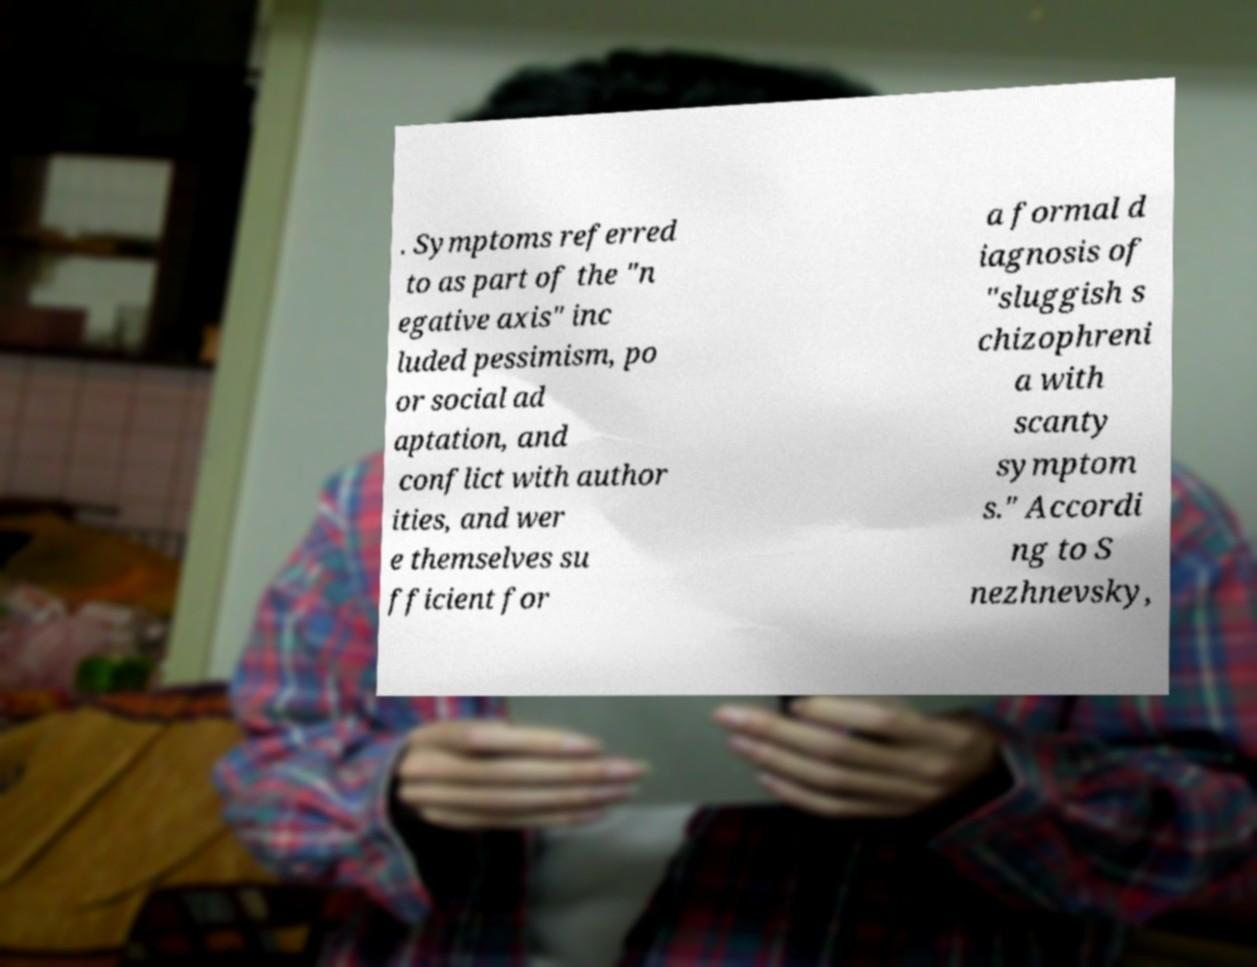Please read and relay the text visible in this image. What does it say? . Symptoms referred to as part of the "n egative axis" inc luded pessimism, po or social ad aptation, and conflict with author ities, and wer e themselves su fficient for a formal d iagnosis of "sluggish s chizophreni a with scanty symptom s." Accordi ng to S nezhnevsky, 